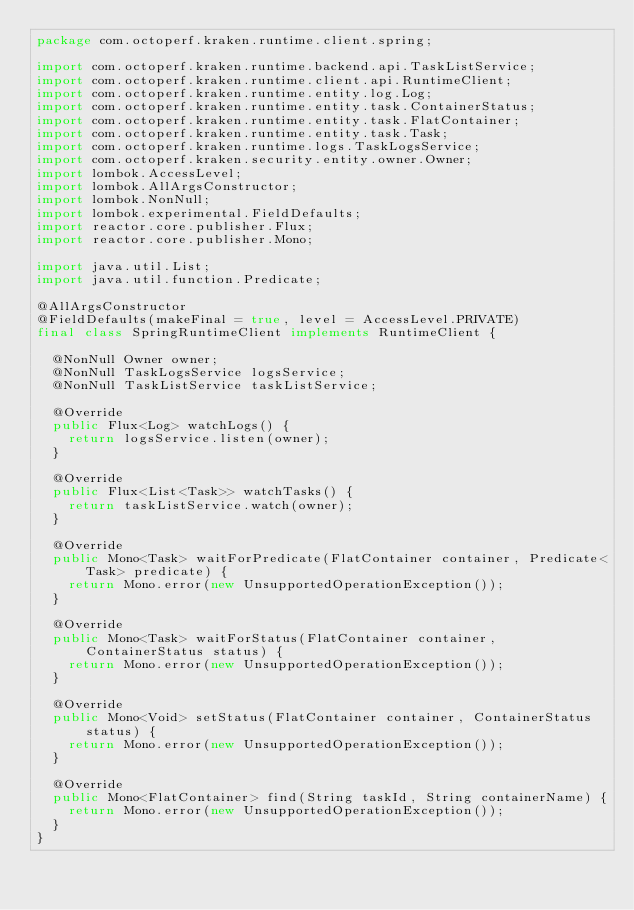Convert code to text. <code><loc_0><loc_0><loc_500><loc_500><_Java_>package com.octoperf.kraken.runtime.client.spring;

import com.octoperf.kraken.runtime.backend.api.TaskListService;
import com.octoperf.kraken.runtime.client.api.RuntimeClient;
import com.octoperf.kraken.runtime.entity.log.Log;
import com.octoperf.kraken.runtime.entity.task.ContainerStatus;
import com.octoperf.kraken.runtime.entity.task.FlatContainer;
import com.octoperf.kraken.runtime.entity.task.Task;
import com.octoperf.kraken.runtime.logs.TaskLogsService;
import com.octoperf.kraken.security.entity.owner.Owner;
import lombok.AccessLevel;
import lombok.AllArgsConstructor;
import lombok.NonNull;
import lombok.experimental.FieldDefaults;
import reactor.core.publisher.Flux;
import reactor.core.publisher.Mono;

import java.util.List;
import java.util.function.Predicate;

@AllArgsConstructor
@FieldDefaults(makeFinal = true, level = AccessLevel.PRIVATE)
final class SpringRuntimeClient implements RuntimeClient {

  @NonNull Owner owner;
  @NonNull TaskLogsService logsService;
  @NonNull TaskListService taskListService;

  @Override
  public Flux<Log> watchLogs() {
    return logsService.listen(owner);
  }

  @Override
  public Flux<List<Task>> watchTasks() {
    return taskListService.watch(owner);
  }

  @Override
  public Mono<Task> waitForPredicate(FlatContainer container, Predicate<Task> predicate) {
    return Mono.error(new UnsupportedOperationException());
  }

  @Override
  public Mono<Task> waitForStatus(FlatContainer container, ContainerStatus status) {
    return Mono.error(new UnsupportedOperationException());
  }

  @Override
  public Mono<Void> setStatus(FlatContainer container, ContainerStatus status) {
    return Mono.error(new UnsupportedOperationException());
  }

  @Override
  public Mono<FlatContainer> find(String taskId, String containerName) {
    return Mono.error(new UnsupportedOperationException());
  }
}
</code> 